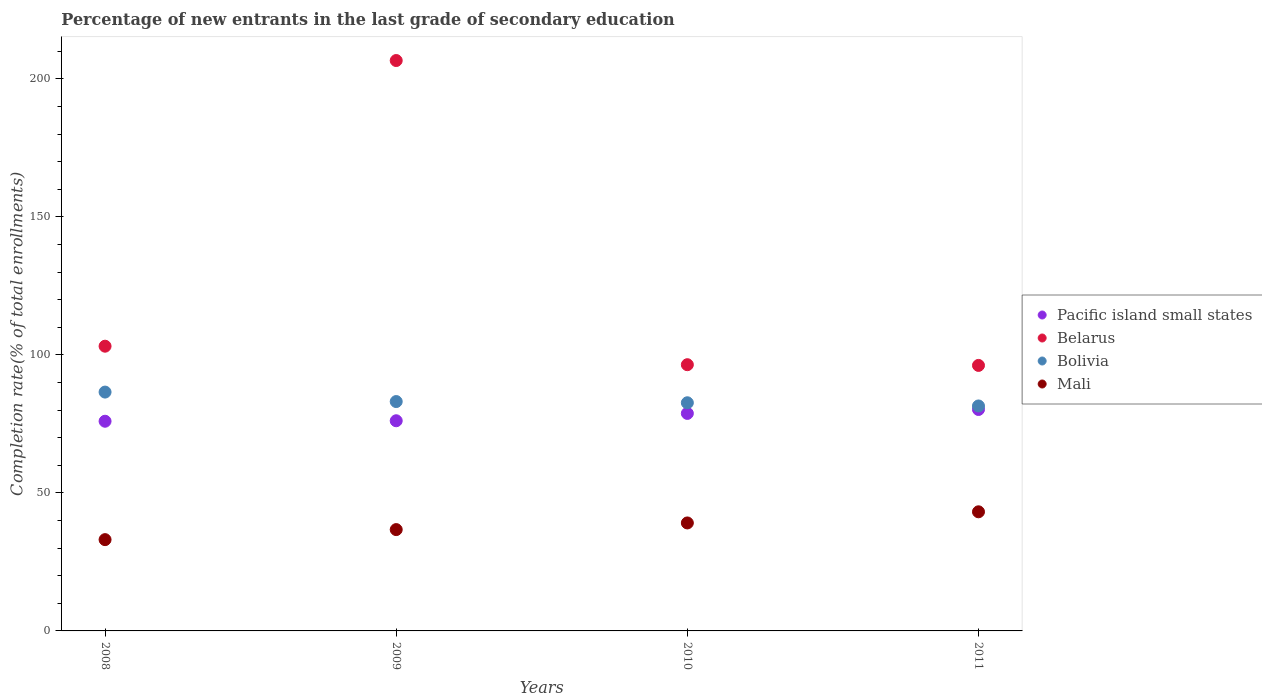What is the percentage of new entrants in Mali in 2008?
Your response must be concise. 33.07. Across all years, what is the maximum percentage of new entrants in Mali?
Keep it short and to the point. 43.15. Across all years, what is the minimum percentage of new entrants in Bolivia?
Your answer should be compact. 81.5. In which year was the percentage of new entrants in Pacific island small states maximum?
Offer a terse response. 2011. In which year was the percentage of new entrants in Pacific island small states minimum?
Your answer should be compact. 2008. What is the total percentage of new entrants in Belarus in the graph?
Provide a succinct answer. 502.39. What is the difference between the percentage of new entrants in Belarus in 2009 and that in 2010?
Offer a terse response. 110.19. What is the difference between the percentage of new entrants in Mali in 2011 and the percentage of new entrants in Bolivia in 2008?
Ensure brevity in your answer.  -43.37. What is the average percentage of new entrants in Belarus per year?
Make the answer very short. 125.6. In the year 2009, what is the difference between the percentage of new entrants in Bolivia and percentage of new entrants in Belarus?
Your response must be concise. -123.54. What is the ratio of the percentage of new entrants in Mali in 2008 to that in 2010?
Your answer should be very brief. 0.85. Is the percentage of new entrants in Belarus in 2009 less than that in 2010?
Keep it short and to the point. No. Is the difference between the percentage of new entrants in Bolivia in 2010 and 2011 greater than the difference between the percentage of new entrants in Belarus in 2010 and 2011?
Your answer should be very brief. Yes. What is the difference between the highest and the second highest percentage of new entrants in Mali?
Provide a succinct answer. 4.04. What is the difference between the highest and the lowest percentage of new entrants in Mali?
Make the answer very short. 10.08. In how many years, is the percentage of new entrants in Belarus greater than the average percentage of new entrants in Belarus taken over all years?
Your response must be concise. 1. Is it the case that in every year, the sum of the percentage of new entrants in Belarus and percentage of new entrants in Mali  is greater than the percentage of new entrants in Bolivia?
Your answer should be very brief. Yes. How many dotlines are there?
Give a very brief answer. 4. How many years are there in the graph?
Make the answer very short. 4. What is the difference between two consecutive major ticks on the Y-axis?
Provide a short and direct response. 50. Does the graph contain any zero values?
Offer a very short reply. No. How many legend labels are there?
Offer a terse response. 4. How are the legend labels stacked?
Your response must be concise. Vertical. What is the title of the graph?
Ensure brevity in your answer.  Percentage of new entrants in the last grade of secondary education. Does "Latin America(all income levels)" appear as one of the legend labels in the graph?
Provide a succinct answer. No. What is the label or title of the Y-axis?
Make the answer very short. Completion rate(% of total enrollments). What is the Completion rate(% of total enrollments) in Pacific island small states in 2008?
Offer a terse response. 75.96. What is the Completion rate(% of total enrollments) of Belarus in 2008?
Provide a short and direct response. 103.14. What is the Completion rate(% of total enrollments) in Bolivia in 2008?
Provide a succinct answer. 86.52. What is the Completion rate(% of total enrollments) of Mali in 2008?
Ensure brevity in your answer.  33.07. What is the Completion rate(% of total enrollments) in Pacific island small states in 2009?
Offer a very short reply. 76.13. What is the Completion rate(% of total enrollments) in Belarus in 2009?
Your answer should be compact. 206.63. What is the Completion rate(% of total enrollments) of Bolivia in 2009?
Your response must be concise. 83.09. What is the Completion rate(% of total enrollments) of Mali in 2009?
Your response must be concise. 36.71. What is the Completion rate(% of total enrollments) in Pacific island small states in 2010?
Ensure brevity in your answer.  78.79. What is the Completion rate(% of total enrollments) in Belarus in 2010?
Provide a short and direct response. 96.44. What is the Completion rate(% of total enrollments) in Bolivia in 2010?
Make the answer very short. 82.65. What is the Completion rate(% of total enrollments) in Mali in 2010?
Provide a succinct answer. 39.11. What is the Completion rate(% of total enrollments) in Pacific island small states in 2011?
Provide a short and direct response. 80.21. What is the Completion rate(% of total enrollments) of Belarus in 2011?
Ensure brevity in your answer.  96.18. What is the Completion rate(% of total enrollments) in Bolivia in 2011?
Your response must be concise. 81.5. What is the Completion rate(% of total enrollments) of Mali in 2011?
Provide a succinct answer. 43.15. Across all years, what is the maximum Completion rate(% of total enrollments) of Pacific island small states?
Provide a succinct answer. 80.21. Across all years, what is the maximum Completion rate(% of total enrollments) of Belarus?
Give a very brief answer. 206.63. Across all years, what is the maximum Completion rate(% of total enrollments) of Bolivia?
Your response must be concise. 86.52. Across all years, what is the maximum Completion rate(% of total enrollments) of Mali?
Your answer should be compact. 43.15. Across all years, what is the minimum Completion rate(% of total enrollments) in Pacific island small states?
Offer a very short reply. 75.96. Across all years, what is the minimum Completion rate(% of total enrollments) of Belarus?
Keep it short and to the point. 96.18. Across all years, what is the minimum Completion rate(% of total enrollments) of Bolivia?
Make the answer very short. 81.5. Across all years, what is the minimum Completion rate(% of total enrollments) in Mali?
Your answer should be very brief. 33.07. What is the total Completion rate(% of total enrollments) of Pacific island small states in the graph?
Offer a very short reply. 311.1. What is the total Completion rate(% of total enrollments) in Belarus in the graph?
Offer a very short reply. 502.39. What is the total Completion rate(% of total enrollments) in Bolivia in the graph?
Make the answer very short. 333.75. What is the total Completion rate(% of total enrollments) in Mali in the graph?
Your answer should be very brief. 152.04. What is the difference between the Completion rate(% of total enrollments) in Pacific island small states in 2008 and that in 2009?
Offer a terse response. -0.17. What is the difference between the Completion rate(% of total enrollments) of Belarus in 2008 and that in 2009?
Make the answer very short. -103.49. What is the difference between the Completion rate(% of total enrollments) of Bolivia in 2008 and that in 2009?
Your answer should be compact. 3.43. What is the difference between the Completion rate(% of total enrollments) of Mali in 2008 and that in 2009?
Your response must be concise. -3.64. What is the difference between the Completion rate(% of total enrollments) in Pacific island small states in 2008 and that in 2010?
Your answer should be compact. -2.84. What is the difference between the Completion rate(% of total enrollments) in Belarus in 2008 and that in 2010?
Make the answer very short. 6.7. What is the difference between the Completion rate(% of total enrollments) in Bolivia in 2008 and that in 2010?
Your response must be concise. 3.87. What is the difference between the Completion rate(% of total enrollments) in Mali in 2008 and that in 2010?
Provide a short and direct response. -6.05. What is the difference between the Completion rate(% of total enrollments) in Pacific island small states in 2008 and that in 2011?
Make the answer very short. -4.26. What is the difference between the Completion rate(% of total enrollments) in Belarus in 2008 and that in 2011?
Keep it short and to the point. 6.96. What is the difference between the Completion rate(% of total enrollments) of Bolivia in 2008 and that in 2011?
Give a very brief answer. 5.03. What is the difference between the Completion rate(% of total enrollments) of Mali in 2008 and that in 2011?
Offer a very short reply. -10.08. What is the difference between the Completion rate(% of total enrollments) in Pacific island small states in 2009 and that in 2010?
Keep it short and to the point. -2.66. What is the difference between the Completion rate(% of total enrollments) of Belarus in 2009 and that in 2010?
Ensure brevity in your answer.  110.19. What is the difference between the Completion rate(% of total enrollments) of Bolivia in 2009 and that in 2010?
Offer a very short reply. 0.44. What is the difference between the Completion rate(% of total enrollments) of Mali in 2009 and that in 2010?
Offer a very short reply. -2.41. What is the difference between the Completion rate(% of total enrollments) in Pacific island small states in 2009 and that in 2011?
Ensure brevity in your answer.  -4.08. What is the difference between the Completion rate(% of total enrollments) of Belarus in 2009 and that in 2011?
Keep it short and to the point. 110.45. What is the difference between the Completion rate(% of total enrollments) in Bolivia in 2009 and that in 2011?
Offer a terse response. 1.59. What is the difference between the Completion rate(% of total enrollments) of Mali in 2009 and that in 2011?
Your answer should be compact. -6.44. What is the difference between the Completion rate(% of total enrollments) in Pacific island small states in 2010 and that in 2011?
Provide a succinct answer. -1.42. What is the difference between the Completion rate(% of total enrollments) in Belarus in 2010 and that in 2011?
Your answer should be very brief. 0.26. What is the difference between the Completion rate(% of total enrollments) of Bolivia in 2010 and that in 2011?
Provide a succinct answer. 1.15. What is the difference between the Completion rate(% of total enrollments) in Mali in 2010 and that in 2011?
Offer a very short reply. -4.04. What is the difference between the Completion rate(% of total enrollments) in Pacific island small states in 2008 and the Completion rate(% of total enrollments) in Belarus in 2009?
Make the answer very short. -130.67. What is the difference between the Completion rate(% of total enrollments) of Pacific island small states in 2008 and the Completion rate(% of total enrollments) of Bolivia in 2009?
Provide a short and direct response. -7.13. What is the difference between the Completion rate(% of total enrollments) of Pacific island small states in 2008 and the Completion rate(% of total enrollments) of Mali in 2009?
Your response must be concise. 39.25. What is the difference between the Completion rate(% of total enrollments) of Belarus in 2008 and the Completion rate(% of total enrollments) of Bolivia in 2009?
Provide a short and direct response. 20.05. What is the difference between the Completion rate(% of total enrollments) of Belarus in 2008 and the Completion rate(% of total enrollments) of Mali in 2009?
Your answer should be very brief. 66.43. What is the difference between the Completion rate(% of total enrollments) in Bolivia in 2008 and the Completion rate(% of total enrollments) in Mali in 2009?
Your response must be concise. 49.81. What is the difference between the Completion rate(% of total enrollments) of Pacific island small states in 2008 and the Completion rate(% of total enrollments) of Belarus in 2010?
Offer a very short reply. -20.48. What is the difference between the Completion rate(% of total enrollments) in Pacific island small states in 2008 and the Completion rate(% of total enrollments) in Bolivia in 2010?
Your answer should be very brief. -6.69. What is the difference between the Completion rate(% of total enrollments) in Pacific island small states in 2008 and the Completion rate(% of total enrollments) in Mali in 2010?
Ensure brevity in your answer.  36.84. What is the difference between the Completion rate(% of total enrollments) of Belarus in 2008 and the Completion rate(% of total enrollments) of Bolivia in 2010?
Ensure brevity in your answer.  20.49. What is the difference between the Completion rate(% of total enrollments) of Belarus in 2008 and the Completion rate(% of total enrollments) of Mali in 2010?
Offer a terse response. 64.03. What is the difference between the Completion rate(% of total enrollments) in Bolivia in 2008 and the Completion rate(% of total enrollments) in Mali in 2010?
Keep it short and to the point. 47.41. What is the difference between the Completion rate(% of total enrollments) of Pacific island small states in 2008 and the Completion rate(% of total enrollments) of Belarus in 2011?
Your response must be concise. -20.22. What is the difference between the Completion rate(% of total enrollments) of Pacific island small states in 2008 and the Completion rate(% of total enrollments) of Bolivia in 2011?
Keep it short and to the point. -5.54. What is the difference between the Completion rate(% of total enrollments) in Pacific island small states in 2008 and the Completion rate(% of total enrollments) in Mali in 2011?
Your answer should be compact. 32.81. What is the difference between the Completion rate(% of total enrollments) of Belarus in 2008 and the Completion rate(% of total enrollments) of Bolivia in 2011?
Offer a very short reply. 21.65. What is the difference between the Completion rate(% of total enrollments) in Belarus in 2008 and the Completion rate(% of total enrollments) in Mali in 2011?
Offer a very short reply. 59.99. What is the difference between the Completion rate(% of total enrollments) of Bolivia in 2008 and the Completion rate(% of total enrollments) of Mali in 2011?
Provide a succinct answer. 43.37. What is the difference between the Completion rate(% of total enrollments) of Pacific island small states in 2009 and the Completion rate(% of total enrollments) of Belarus in 2010?
Your answer should be compact. -20.31. What is the difference between the Completion rate(% of total enrollments) in Pacific island small states in 2009 and the Completion rate(% of total enrollments) in Bolivia in 2010?
Make the answer very short. -6.51. What is the difference between the Completion rate(% of total enrollments) in Pacific island small states in 2009 and the Completion rate(% of total enrollments) in Mali in 2010?
Make the answer very short. 37.02. What is the difference between the Completion rate(% of total enrollments) in Belarus in 2009 and the Completion rate(% of total enrollments) in Bolivia in 2010?
Offer a terse response. 123.98. What is the difference between the Completion rate(% of total enrollments) in Belarus in 2009 and the Completion rate(% of total enrollments) in Mali in 2010?
Make the answer very short. 167.51. What is the difference between the Completion rate(% of total enrollments) in Bolivia in 2009 and the Completion rate(% of total enrollments) in Mali in 2010?
Ensure brevity in your answer.  43.97. What is the difference between the Completion rate(% of total enrollments) of Pacific island small states in 2009 and the Completion rate(% of total enrollments) of Belarus in 2011?
Your answer should be very brief. -20.05. What is the difference between the Completion rate(% of total enrollments) in Pacific island small states in 2009 and the Completion rate(% of total enrollments) in Bolivia in 2011?
Provide a short and direct response. -5.36. What is the difference between the Completion rate(% of total enrollments) in Pacific island small states in 2009 and the Completion rate(% of total enrollments) in Mali in 2011?
Offer a terse response. 32.98. What is the difference between the Completion rate(% of total enrollments) of Belarus in 2009 and the Completion rate(% of total enrollments) of Bolivia in 2011?
Make the answer very short. 125.13. What is the difference between the Completion rate(% of total enrollments) of Belarus in 2009 and the Completion rate(% of total enrollments) of Mali in 2011?
Provide a succinct answer. 163.48. What is the difference between the Completion rate(% of total enrollments) of Bolivia in 2009 and the Completion rate(% of total enrollments) of Mali in 2011?
Keep it short and to the point. 39.94. What is the difference between the Completion rate(% of total enrollments) in Pacific island small states in 2010 and the Completion rate(% of total enrollments) in Belarus in 2011?
Give a very brief answer. -17.39. What is the difference between the Completion rate(% of total enrollments) in Pacific island small states in 2010 and the Completion rate(% of total enrollments) in Bolivia in 2011?
Offer a terse response. -2.7. What is the difference between the Completion rate(% of total enrollments) of Pacific island small states in 2010 and the Completion rate(% of total enrollments) of Mali in 2011?
Your answer should be very brief. 35.64. What is the difference between the Completion rate(% of total enrollments) in Belarus in 2010 and the Completion rate(% of total enrollments) in Bolivia in 2011?
Provide a succinct answer. 14.94. What is the difference between the Completion rate(% of total enrollments) in Belarus in 2010 and the Completion rate(% of total enrollments) in Mali in 2011?
Ensure brevity in your answer.  53.29. What is the difference between the Completion rate(% of total enrollments) in Bolivia in 2010 and the Completion rate(% of total enrollments) in Mali in 2011?
Your response must be concise. 39.5. What is the average Completion rate(% of total enrollments) of Pacific island small states per year?
Your answer should be compact. 77.77. What is the average Completion rate(% of total enrollments) of Belarus per year?
Give a very brief answer. 125.6. What is the average Completion rate(% of total enrollments) in Bolivia per year?
Make the answer very short. 83.44. What is the average Completion rate(% of total enrollments) in Mali per year?
Keep it short and to the point. 38.01. In the year 2008, what is the difference between the Completion rate(% of total enrollments) of Pacific island small states and Completion rate(% of total enrollments) of Belarus?
Ensure brevity in your answer.  -27.18. In the year 2008, what is the difference between the Completion rate(% of total enrollments) in Pacific island small states and Completion rate(% of total enrollments) in Bolivia?
Offer a very short reply. -10.56. In the year 2008, what is the difference between the Completion rate(% of total enrollments) in Pacific island small states and Completion rate(% of total enrollments) in Mali?
Keep it short and to the point. 42.89. In the year 2008, what is the difference between the Completion rate(% of total enrollments) of Belarus and Completion rate(% of total enrollments) of Bolivia?
Provide a short and direct response. 16.62. In the year 2008, what is the difference between the Completion rate(% of total enrollments) of Belarus and Completion rate(% of total enrollments) of Mali?
Provide a succinct answer. 70.07. In the year 2008, what is the difference between the Completion rate(% of total enrollments) of Bolivia and Completion rate(% of total enrollments) of Mali?
Ensure brevity in your answer.  53.45. In the year 2009, what is the difference between the Completion rate(% of total enrollments) of Pacific island small states and Completion rate(% of total enrollments) of Belarus?
Make the answer very short. -130.49. In the year 2009, what is the difference between the Completion rate(% of total enrollments) in Pacific island small states and Completion rate(% of total enrollments) in Bolivia?
Keep it short and to the point. -6.96. In the year 2009, what is the difference between the Completion rate(% of total enrollments) in Pacific island small states and Completion rate(% of total enrollments) in Mali?
Make the answer very short. 39.43. In the year 2009, what is the difference between the Completion rate(% of total enrollments) of Belarus and Completion rate(% of total enrollments) of Bolivia?
Offer a terse response. 123.54. In the year 2009, what is the difference between the Completion rate(% of total enrollments) of Belarus and Completion rate(% of total enrollments) of Mali?
Your answer should be compact. 169.92. In the year 2009, what is the difference between the Completion rate(% of total enrollments) of Bolivia and Completion rate(% of total enrollments) of Mali?
Keep it short and to the point. 46.38. In the year 2010, what is the difference between the Completion rate(% of total enrollments) in Pacific island small states and Completion rate(% of total enrollments) in Belarus?
Offer a terse response. -17.64. In the year 2010, what is the difference between the Completion rate(% of total enrollments) in Pacific island small states and Completion rate(% of total enrollments) in Bolivia?
Keep it short and to the point. -3.85. In the year 2010, what is the difference between the Completion rate(% of total enrollments) in Pacific island small states and Completion rate(% of total enrollments) in Mali?
Offer a terse response. 39.68. In the year 2010, what is the difference between the Completion rate(% of total enrollments) of Belarus and Completion rate(% of total enrollments) of Bolivia?
Your answer should be compact. 13.79. In the year 2010, what is the difference between the Completion rate(% of total enrollments) of Belarus and Completion rate(% of total enrollments) of Mali?
Keep it short and to the point. 57.32. In the year 2010, what is the difference between the Completion rate(% of total enrollments) in Bolivia and Completion rate(% of total enrollments) in Mali?
Offer a very short reply. 43.53. In the year 2011, what is the difference between the Completion rate(% of total enrollments) of Pacific island small states and Completion rate(% of total enrollments) of Belarus?
Your answer should be very brief. -15.97. In the year 2011, what is the difference between the Completion rate(% of total enrollments) of Pacific island small states and Completion rate(% of total enrollments) of Bolivia?
Offer a very short reply. -1.28. In the year 2011, what is the difference between the Completion rate(% of total enrollments) in Pacific island small states and Completion rate(% of total enrollments) in Mali?
Keep it short and to the point. 37.06. In the year 2011, what is the difference between the Completion rate(% of total enrollments) in Belarus and Completion rate(% of total enrollments) in Bolivia?
Your answer should be very brief. 14.68. In the year 2011, what is the difference between the Completion rate(% of total enrollments) of Belarus and Completion rate(% of total enrollments) of Mali?
Provide a succinct answer. 53.03. In the year 2011, what is the difference between the Completion rate(% of total enrollments) in Bolivia and Completion rate(% of total enrollments) in Mali?
Provide a succinct answer. 38.35. What is the ratio of the Completion rate(% of total enrollments) of Pacific island small states in 2008 to that in 2009?
Your answer should be compact. 1. What is the ratio of the Completion rate(% of total enrollments) in Belarus in 2008 to that in 2009?
Ensure brevity in your answer.  0.5. What is the ratio of the Completion rate(% of total enrollments) of Bolivia in 2008 to that in 2009?
Your answer should be very brief. 1.04. What is the ratio of the Completion rate(% of total enrollments) of Mali in 2008 to that in 2009?
Provide a short and direct response. 0.9. What is the ratio of the Completion rate(% of total enrollments) in Belarus in 2008 to that in 2010?
Your response must be concise. 1.07. What is the ratio of the Completion rate(% of total enrollments) of Bolivia in 2008 to that in 2010?
Ensure brevity in your answer.  1.05. What is the ratio of the Completion rate(% of total enrollments) in Mali in 2008 to that in 2010?
Your answer should be compact. 0.85. What is the ratio of the Completion rate(% of total enrollments) in Pacific island small states in 2008 to that in 2011?
Offer a terse response. 0.95. What is the ratio of the Completion rate(% of total enrollments) of Belarus in 2008 to that in 2011?
Your answer should be compact. 1.07. What is the ratio of the Completion rate(% of total enrollments) of Bolivia in 2008 to that in 2011?
Your answer should be very brief. 1.06. What is the ratio of the Completion rate(% of total enrollments) of Mali in 2008 to that in 2011?
Give a very brief answer. 0.77. What is the ratio of the Completion rate(% of total enrollments) of Pacific island small states in 2009 to that in 2010?
Give a very brief answer. 0.97. What is the ratio of the Completion rate(% of total enrollments) in Belarus in 2009 to that in 2010?
Make the answer very short. 2.14. What is the ratio of the Completion rate(% of total enrollments) of Bolivia in 2009 to that in 2010?
Your answer should be very brief. 1.01. What is the ratio of the Completion rate(% of total enrollments) in Mali in 2009 to that in 2010?
Offer a terse response. 0.94. What is the ratio of the Completion rate(% of total enrollments) in Pacific island small states in 2009 to that in 2011?
Provide a succinct answer. 0.95. What is the ratio of the Completion rate(% of total enrollments) in Belarus in 2009 to that in 2011?
Your answer should be very brief. 2.15. What is the ratio of the Completion rate(% of total enrollments) in Bolivia in 2009 to that in 2011?
Ensure brevity in your answer.  1.02. What is the ratio of the Completion rate(% of total enrollments) in Mali in 2009 to that in 2011?
Offer a terse response. 0.85. What is the ratio of the Completion rate(% of total enrollments) in Pacific island small states in 2010 to that in 2011?
Provide a short and direct response. 0.98. What is the ratio of the Completion rate(% of total enrollments) in Bolivia in 2010 to that in 2011?
Keep it short and to the point. 1.01. What is the ratio of the Completion rate(% of total enrollments) of Mali in 2010 to that in 2011?
Provide a short and direct response. 0.91. What is the difference between the highest and the second highest Completion rate(% of total enrollments) of Pacific island small states?
Your answer should be very brief. 1.42. What is the difference between the highest and the second highest Completion rate(% of total enrollments) in Belarus?
Ensure brevity in your answer.  103.49. What is the difference between the highest and the second highest Completion rate(% of total enrollments) in Bolivia?
Make the answer very short. 3.43. What is the difference between the highest and the second highest Completion rate(% of total enrollments) of Mali?
Your answer should be compact. 4.04. What is the difference between the highest and the lowest Completion rate(% of total enrollments) of Pacific island small states?
Your answer should be very brief. 4.26. What is the difference between the highest and the lowest Completion rate(% of total enrollments) in Belarus?
Make the answer very short. 110.45. What is the difference between the highest and the lowest Completion rate(% of total enrollments) in Bolivia?
Make the answer very short. 5.03. What is the difference between the highest and the lowest Completion rate(% of total enrollments) in Mali?
Provide a succinct answer. 10.08. 